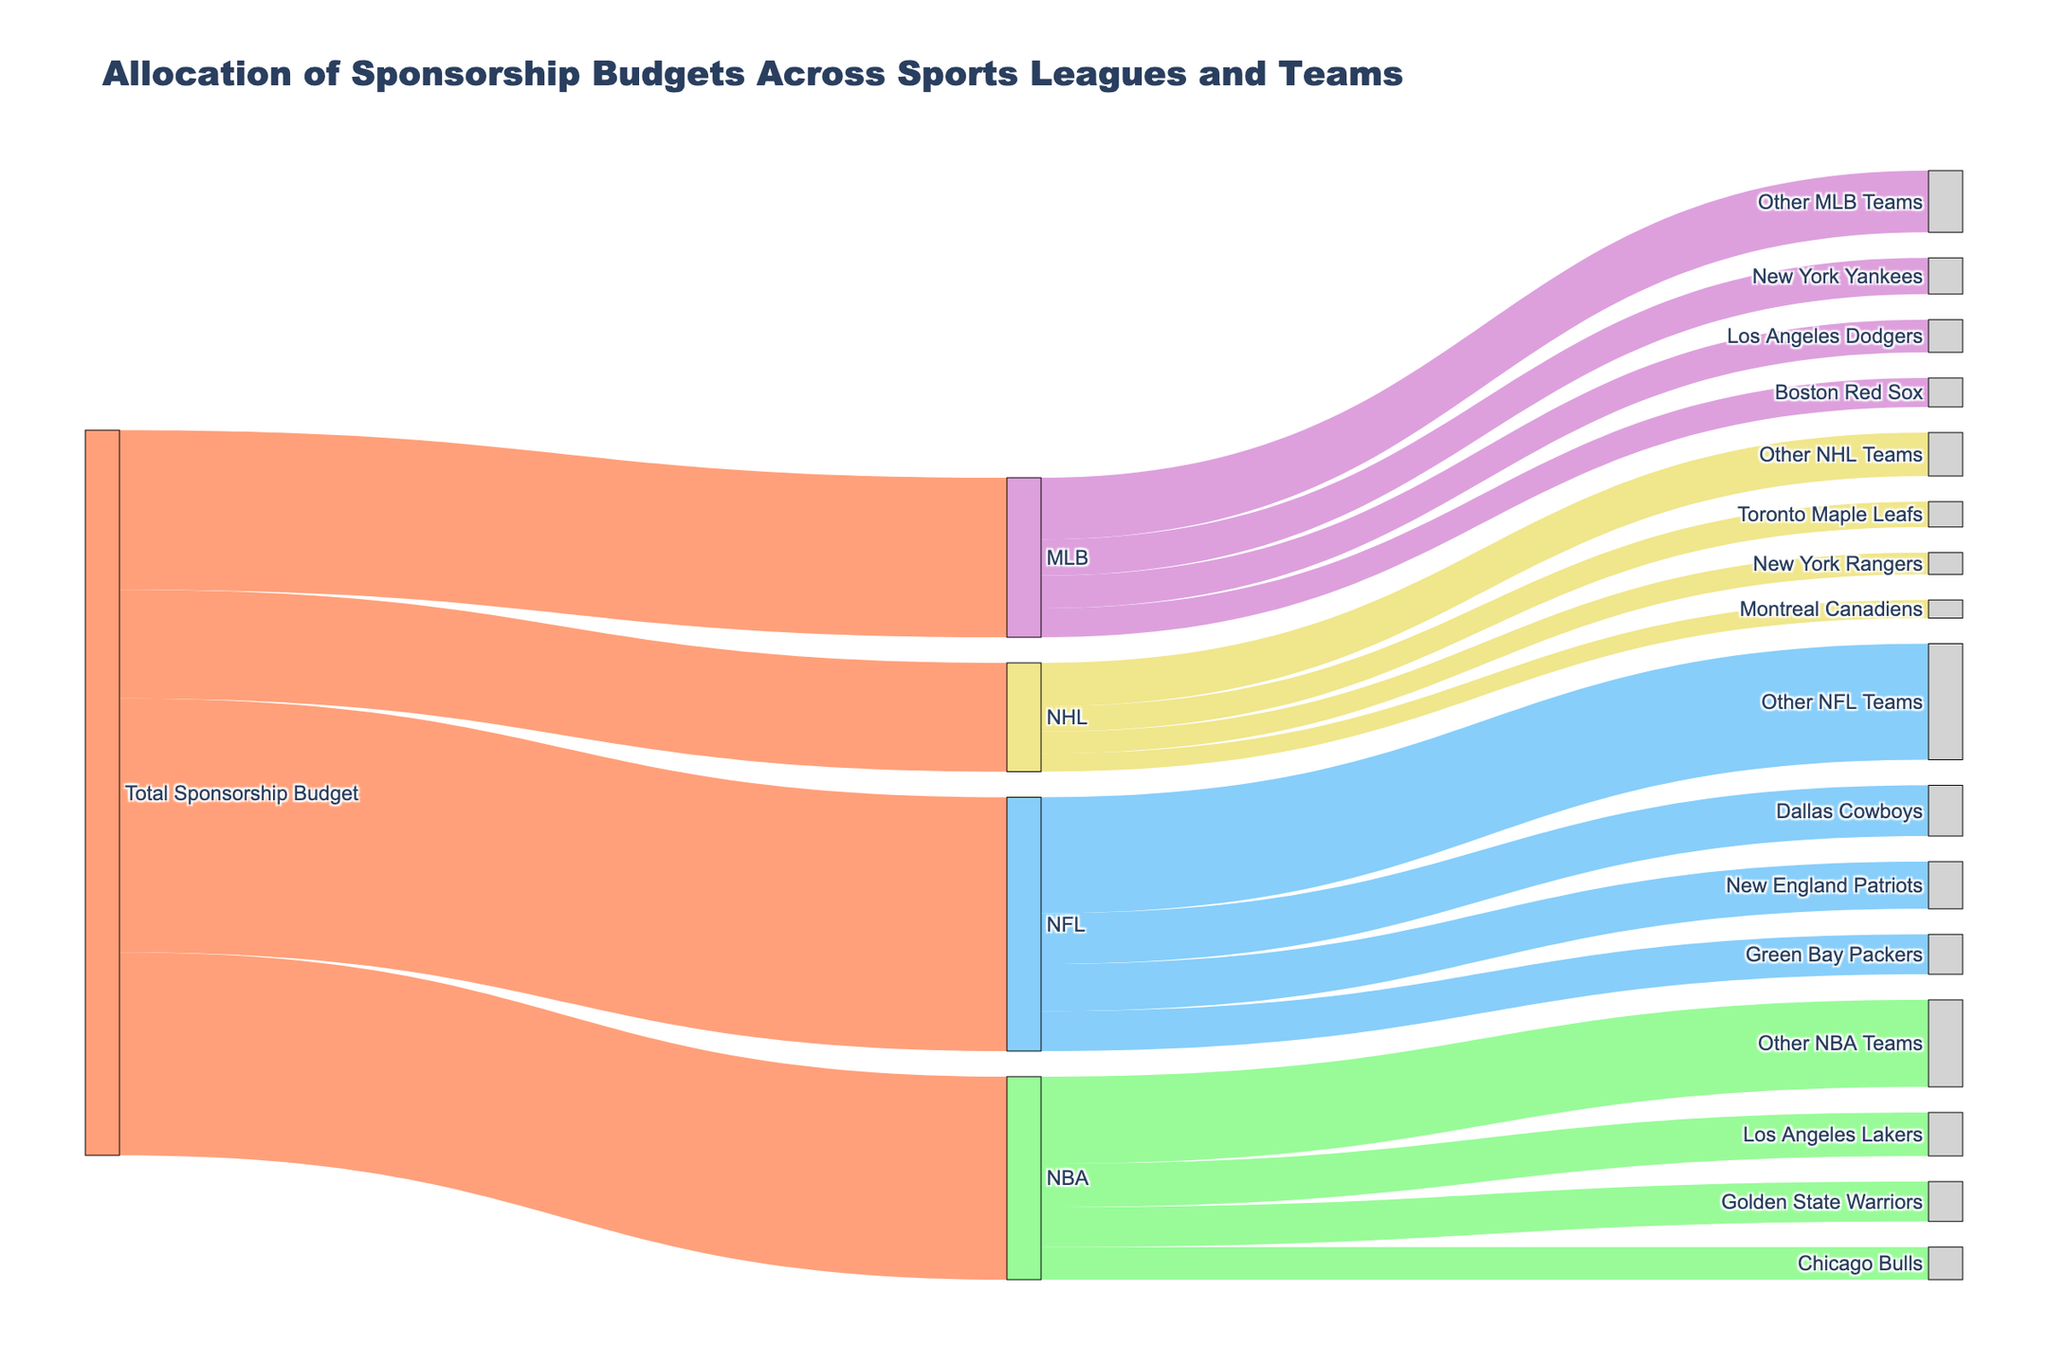What is the total sponsorship budget allocated to the NFL? The figure shows a single flow from "Total Sponsorship Budget" to "NFL" with a value attached. This value represents the total sponsorship budget for the NFL.
Answer: 350 Which team receives the most sponsorship budget in the NBA? In the NBA section, examine the flows from "NBA" to the teams. The flow with the highest number indicates the team with the most sponsorship budget.
Answer: Los Angeles Lakers What is the difference in sponsorship budget between the New York Yankees and the Boston Red Sox? Find the values for the New York Yankees and the Boston Red Sox in the MLB section. Subtract the Boston Red Sox's value from the New York Yankees' value: 50 - 40.
Answer: 10 How much is allocated to "Other NFL Teams"? Look at the NFL section and find the flow labeled "Other NFL Teams" to get the value.
Answer: 160 Which sports league receives the least sponsorship budget? Compare the total values allocated to each league (NFL, NBA, MLB, NHL) and find the smallest value.
Answer: NHL What is the total sponsorship amount allocated to the Los Angeles Lakers and the Golden State Warriors combined? Add the values allocated to the Los Angeles Lakers and the Golden State Warriors in the NBA section: 60 + 55.
Answer: 115 How much sponsorship is allocated to the top 3 NFL teams combined? Add the values for the Dallas Cowboys, New England Patriots, and Green Bay Packers in the NFL section: 70 + 65 + 55.
Answer: 190 Which NHL team receives the highest sponsorship budget? In the NHL section, compare the flows to the teams and find the one with the highest value.
Answer: Toronto Maple Leafs What percentage of the NFL's sponsorship budget goes to the Dallas Cowboys? Divide the Dallas Cowboys' sponsorship budget by the total NFL sponsorship budget and multiply by 100: (70 / 350) * 100.
Answer: 20% 